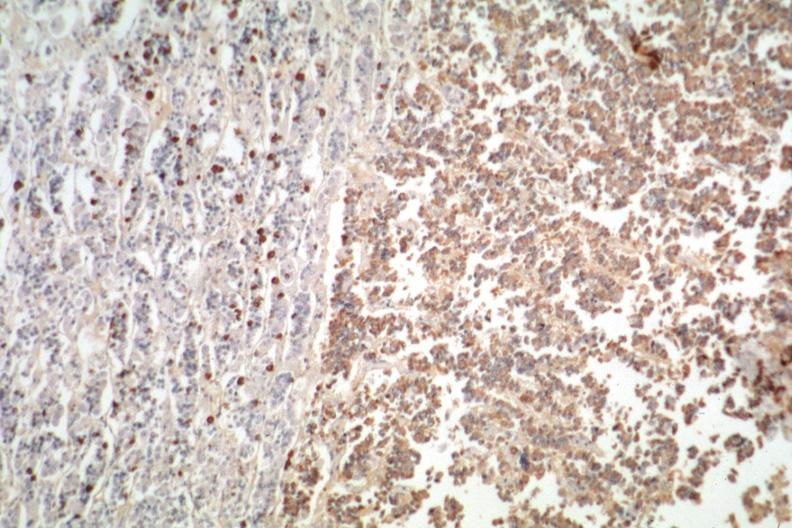what does this image show?
Answer the question using a single word or phrase. Immunostain for growth hormone stain is positive 